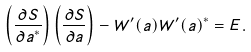Convert formula to latex. <formula><loc_0><loc_0><loc_500><loc_500>\left ( \frac { \partial S } { \partial a ^ { \ast } } \right ) \left ( \frac { \partial S } { \partial a } \right ) - W ^ { \prime } ( a ) W ^ { \prime } ( a ) ^ { \ast } = E .</formula> 